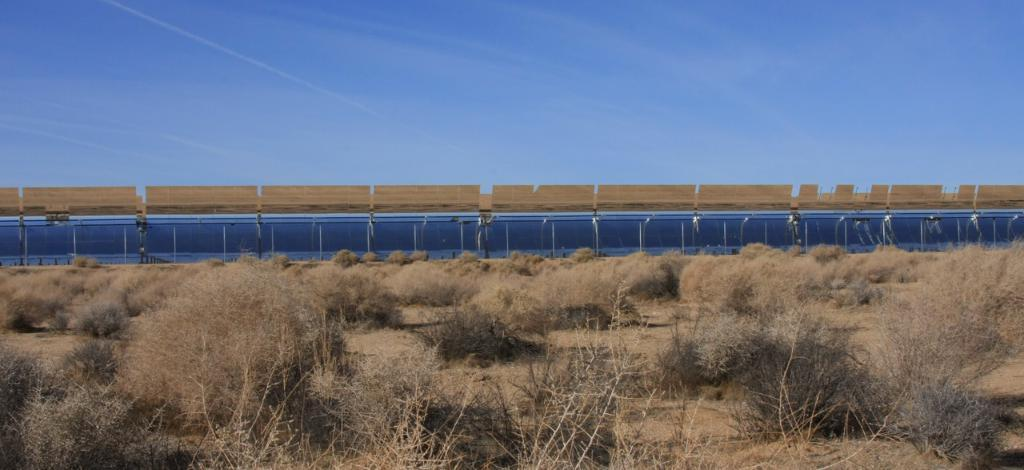What type of vegetation can be seen in the image? There are trees in the image. What structure might be located near the trees in the image? There appears to be a railway station in the background of the image. What is the color of the sky in the image? The sky is blue in the image. What brand of toothpaste is visible on the sofa in the image? There is no toothpaste or sofa present in the image. What type of suit is the person wearing while sitting on the sofa in the image? There is no person or suit present in the image. 